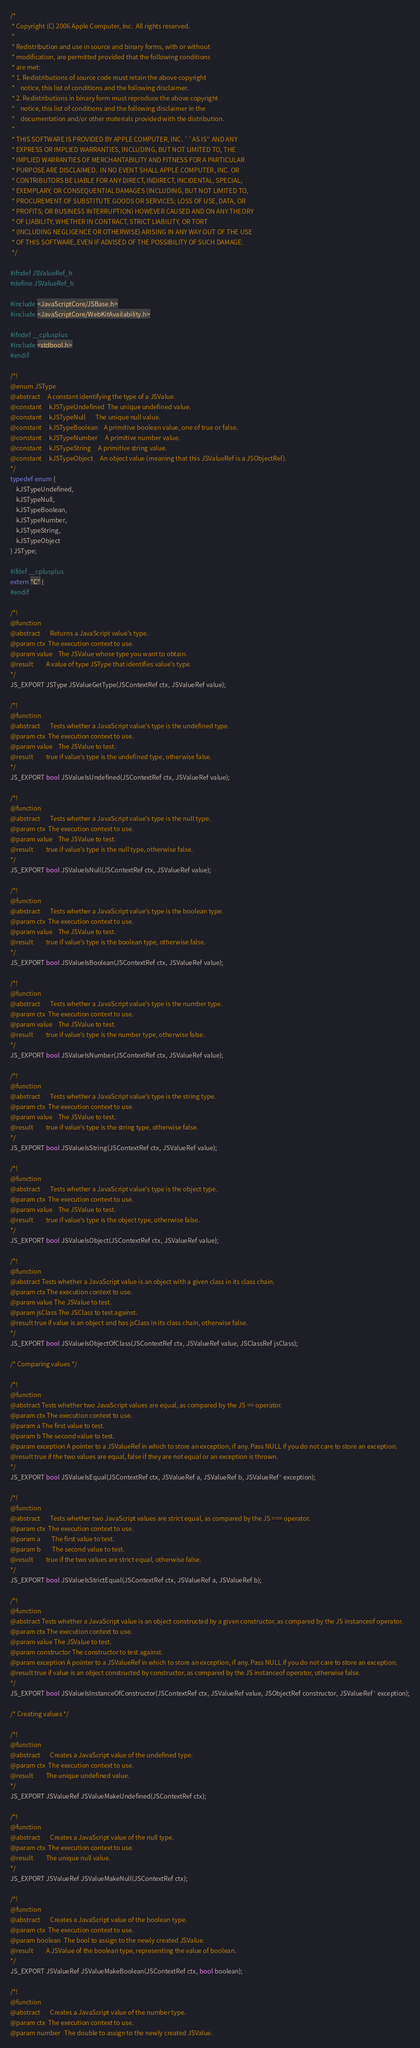Convert code to text. <code><loc_0><loc_0><loc_500><loc_500><_C_>/*
 * Copyright (C) 2006 Apple Computer, Inc.  All rights reserved.
 *
 * Redistribution and use in source and binary forms, with or without
 * modification, are permitted provided that the following conditions
 * are met:
 * 1. Redistributions of source code must retain the above copyright
 *    notice, this list of conditions and the following disclaimer.
 * 2. Redistributions in binary form must reproduce the above copyright
 *    notice, this list of conditions and the following disclaimer in the
 *    documentation and/or other materials provided with the distribution.
 *
 * THIS SOFTWARE IS PROVIDED BY APPLE COMPUTER, INC. ``AS IS'' AND ANY
 * EXPRESS OR IMPLIED WARRANTIES, INCLUDING, BUT NOT LIMITED TO, THE
 * IMPLIED WARRANTIES OF MERCHANTABILITY AND FITNESS FOR A PARTICULAR
 * PURPOSE ARE DISCLAIMED.  IN NO EVENT SHALL APPLE COMPUTER, INC. OR
 * CONTRIBUTORS BE LIABLE FOR ANY DIRECT, INDIRECT, INCIDENTAL, SPECIAL,
 * EXEMPLARY, OR CONSEQUENTIAL DAMAGES (INCLUDING, BUT NOT LIMITED TO,
 * PROCUREMENT OF SUBSTITUTE GOODS OR SERVICES; LOSS OF USE, DATA, OR
 * PROFITS; OR BUSINESS INTERRUPTION) HOWEVER CAUSED AND ON ANY THEORY
 * OF LIABILITY, WHETHER IN CONTRACT, STRICT LIABILITY, OR TORT
 * (INCLUDING NEGLIGENCE OR OTHERWISE) ARISING IN ANY WAY OUT OF THE USE
 * OF THIS SOFTWARE, EVEN IF ADVISED OF THE POSSIBILITY OF SUCH DAMAGE.
 */

#ifndef JSValueRef_h
#define JSValueRef_h

#include <JavaScriptCore/JSBase.h>
#include <JavaScriptCore/WebKitAvailability.h>

#ifndef __cplusplus
#include <stdbool.h>
#endif

/*!
@enum JSType
@abstract     A constant identifying the type of a JSValue.
@constant     kJSTypeUndefined  The unique undefined value.
@constant     kJSTypeNull       The unique null value.
@constant     kJSTypeBoolean    A primitive boolean value, one of true or false.
@constant     kJSTypeNumber     A primitive number value.
@constant     kJSTypeString     A primitive string value.
@constant     kJSTypeObject     An object value (meaning that this JSValueRef is a JSObjectRef).
*/
typedef enum {
    kJSTypeUndefined,
    kJSTypeNull,
    kJSTypeBoolean,
    kJSTypeNumber,
    kJSTypeString,
    kJSTypeObject
} JSType;

#ifdef __cplusplus
extern "C" {
#endif

/*!
@function
@abstract       Returns a JavaScript value's type.
@param ctx  The execution context to use.
@param value    The JSValue whose type you want to obtain.
@result         A value of type JSType that identifies value's type.
*/
JS_EXPORT JSType JSValueGetType(JSContextRef ctx, JSValueRef value);

/*!
@function
@abstract       Tests whether a JavaScript value's type is the undefined type.
@param ctx  The execution context to use.
@param value    The JSValue to test.
@result         true if value's type is the undefined type, otherwise false.
*/
JS_EXPORT bool JSValueIsUndefined(JSContextRef ctx, JSValueRef value);

/*!
@function
@abstract       Tests whether a JavaScript value's type is the null type.
@param ctx  The execution context to use.
@param value    The JSValue to test.
@result         true if value's type is the null type, otherwise false.
*/
JS_EXPORT bool JSValueIsNull(JSContextRef ctx, JSValueRef value);

/*!
@function
@abstract       Tests whether a JavaScript value's type is the boolean type.
@param ctx  The execution context to use.
@param value    The JSValue to test.
@result         true if value's type is the boolean type, otherwise false.
*/
JS_EXPORT bool JSValueIsBoolean(JSContextRef ctx, JSValueRef value);

/*!
@function
@abstract       Tests whether a JavaScript value's type is the number type.
@param ctx  The execution context to use.
@param value    The JSValue to test.
@result         true if value's type is the number type, otherwise false.
*/
JS_EXPORT bool JSValueIsNumber(JSContextRef ctx, JSValueRef value);

/*!
@function
@abstract       Tests whether a JavaScript value's type is the string type.
@param ctx  The execution context to use.
@param value    The JSValue to test.
@result         true if value's type is the string type, otherwise false.
*/
JS_EXPORT bool JSValueIsString(JSContextRef ctx, JSValueRef value);

/*!
@function
@abstract       Tests whether a JavaScript value's type is the object type.
@param ctx  The execution context to use.
@param value    The JSValue to test.
@result         true if value's type is the object type, otherwise false.
*/
JS_EXPORT bool JSValueIsObject(JSContextRef ctx, JSValueRef value);

/*!
@function
@abstract Tests whether a JavaScript value is an object with a given class in its class chain.
@param ctx The execution context to use.
@param value The JSValue to test.
@param jsClass The JSClass to test against.
@result true if value is an object and has jsClass in its class chain, otherwise false.
*/
JS_EXPORT bool JSValueIsObjectOfClass(JSContextRef ctx, JSValueRef value, JSClassRef jsClass);

/* Comparing values */

/*!
@function
@abstract Tests whether two JavaScript values are equal, as compared by the JS == operator.
@param ctx The execution context to use.
@param a The first value to test.
@param b The second value to test.
@param exception A pointer to a JSValueRef in which to store an exception, if any. Pass NULL if you do not care to store an exception.
@result true if the two values are equal, false if they are not equal or an exception is thrown.
*/
JS_EXPORT bool JSValueIsEqual(JSContextRef ctx, JSValueRef a, JSValueRef b, JSValueRef* exception);

/*!
@function
@abstract       Tests whether two JavaScript values are strict equal, as compared by the JS === operator.
@param ctx  The execution context to use.
@param a        The first value to test.
@param b        The second value to test.
@result         true if the two values are strict equal, otherwise false.
*/
JS_EXPORT bool JSValueIsStrictEqual(JSContextRef ctx, JSValueRef a, JSValueRef b);

/*!
@function
@abstract Tests whether a JavaScript value is an object constructed by a given constructor, as compared by the JS instanceof operator.
@param ctx The execution context to use.
@param value The JSValue to test.
@param constructor The constructor to test against.
@param exception A pointer to a JSValueRef in which to store an exception, if any. Pass NULL if you do not care to store an exception.
@result true if value is an object constructed by constructor, as compared by the JS instanceof operator, otherwise false.
*/
JS_EXPORT bool JSValueIsInstanceOfConstructor(JSContextRef ctx, JSValueRef value, JSObjectRef constructor, JSValueRef* exception);

/* Creating values */

/*!
@function
@abstract       Creates a JavaScript value of the undefined type.
@param ctx  The execution context to use.
@result         The unique undefined value.
*/
JS_EXPORT JSValueRef JSValueMakeUndefined(JSContextRef ctx);

/*!
@function
@abstract       Creates a JavaScript value of the null type.
@param ctx  The execution context to use.
@result         The unique null value.
*/
JS_EXPORT JSValueRef JSValueMakeNull(JSContextRef ctx);

/*!
@function
@abstract       Creates a JavaScript value of the boolean type.
@param ctx  The execution context to use.
@param boolean  The bool to assign to the newly created JSValue.
@result         A JSValue of the boolean type, representing the value of boolean.
*/
JS_EXPORT JSValueRef JSValueMakeBoolean(JSContextRef ctx, bool boolean);

/*!
@function
@abstract       Creates a JavaScript value of the number type.
@param ctx  The execution context to use.
@param number   The double to assign to the newly created JSValue.</code> 